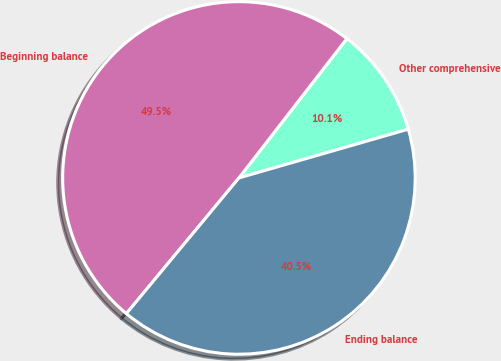<chart> <loc_0><loc_0><loc_500><loc_500><pie_chart><fcel>Other comprehensive<fcel>Beginning balance<fcel>Ending balance<nl><fcel>10.05%<fcel>49.46%<fcel>40.48%<nl></chart> 